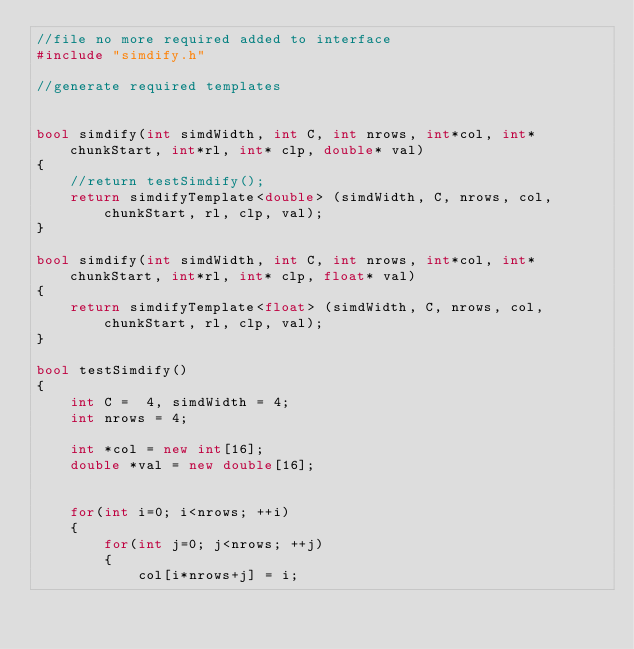<code> <loc_0><loc_0><loc_500><loc_500><_C++_>//file no more required added to interface
#include "simdify.h"

//generate required templates


bool simdify(int simdWidth, int C, int nrows, int*col, int* chunkStart, int*rl, int* clp, double* val)
{
    //return testSimdify();
    return simdifyTemplate<double> (simdWidth, C, nrows, col, chunkStart, rl, clp, val);
}

bool simdify(int simdWidth, int C, int nrows, int*col, int* chunkStart, int*rl, int* clp, float* val)
{
    return simdifyTemplate<float> (simdWidth, C, nrows, col, chunkStart, rl, clp, val);
}

bool testSimdify()
{
    int C =  4, simdWidth = 4;
    int nrows = 4;

    int *col = new int[16];
    double *val = new double[16];


    for(int i=0; i<nrows; ++i)
    {
        for(int j=0; j<nrows; ++j)
        {
            col[i*nrows+j] = i;</code> 